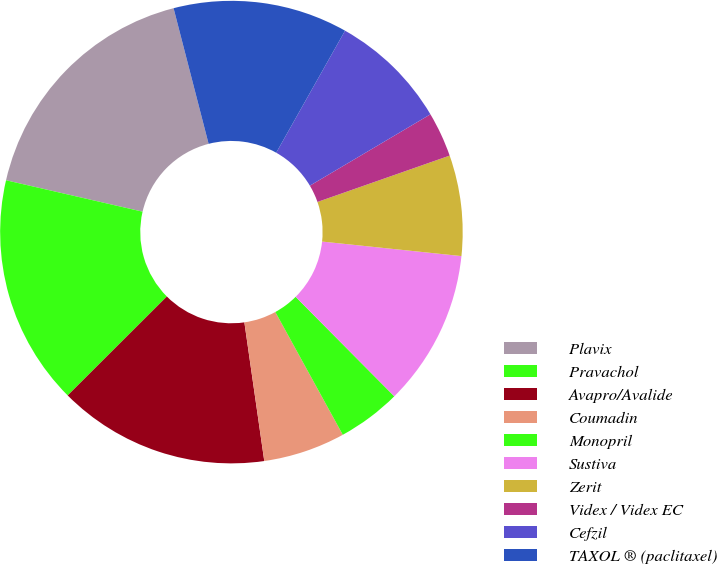<chart> <loc_0><loc_0><loc_500><loc_500><pie_chart><fcel>Plavix<fcel>Pravachol<fcel>Avapro/Avalide<fcel>Coumadin<fcel>Monopril<fcel>Sustiva<fcel>Zerit<fcel>Videx / Videx EC<fcel>Cefzil<fcel>TAXOL ® (paclitaxel)<nl><fcel>17.38%<fcel>16.08%<fcel>14.79%<fcel>5.73%<fcel>4.44%<fcel>10.91%<fcel>7.02%<fcel>3.14%<fcel>8.32%<fcel>12.2%<nl></chart> 